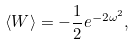<formula> <loc_0><loc_0><loc_500><loc_500>\langle W \rangle = - \frac { 1 } { 2 } e ^ { - 2 \omega ^ { 2 } } ,</formula> 